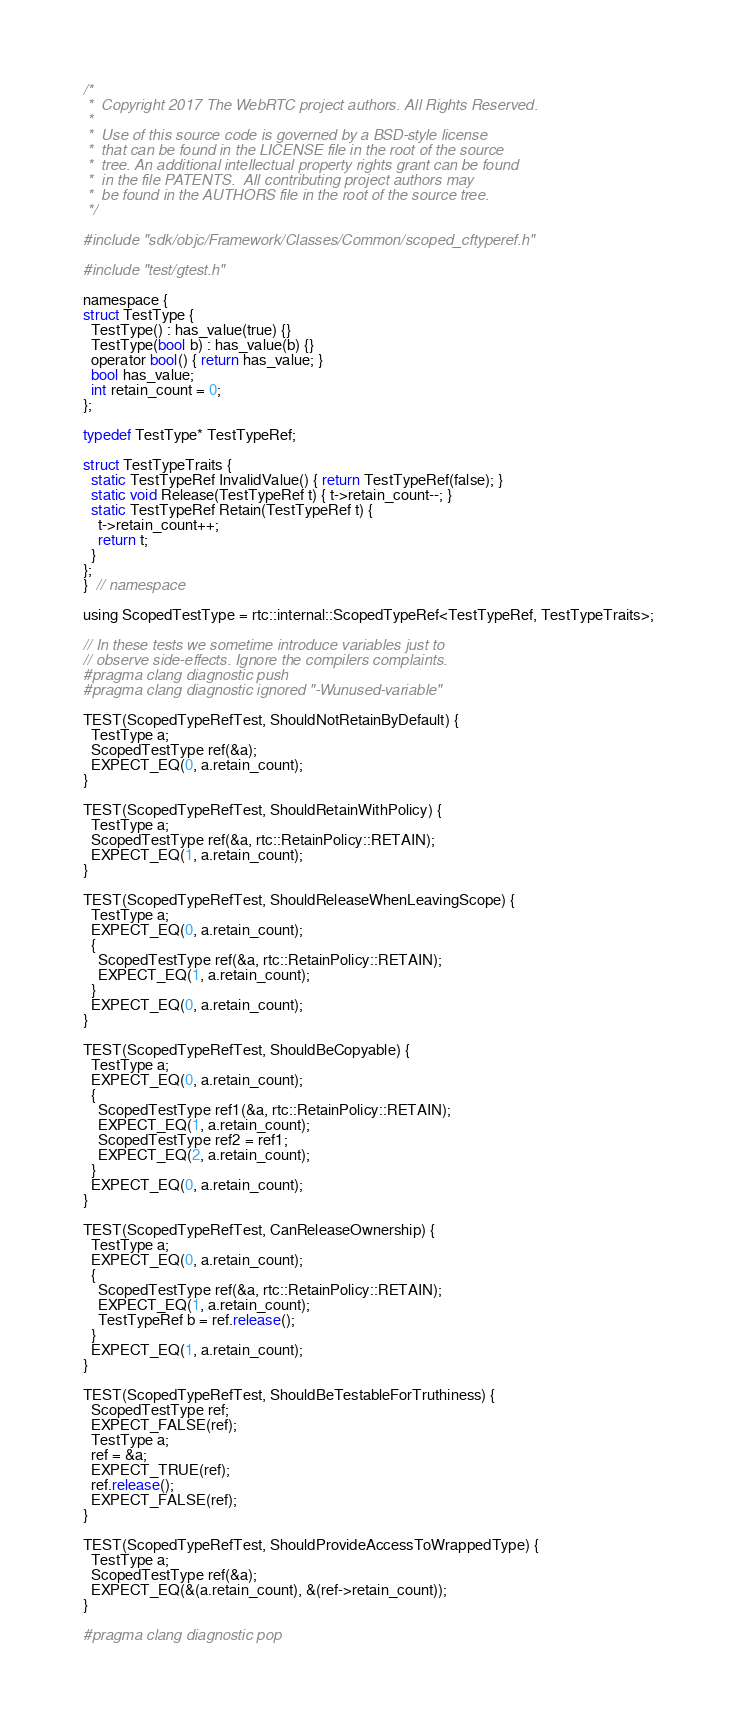Convert code to text. <code><loc_0><loc_0><loc_500><loc_500><_ObjectiveC_>/*
 *  Copyright 2017 The WebRTC project authors. All Rights Reserved.
 *
 *  Use of this source code is governed by a BSD-style license
 *  that can be found in the LICENSE file in the root of the source
 *  tree. An additional intellectual property rights grant can be found
 *  in the file PATENTS.  All contributing project authors may
 *  be found in the AUTHORS file in the root of the source tree.
 */

#include "sdk/objc/Framework/Classes/Common/scoped_cftyperef.h"

#include "test/gtest.h"

namespace {
struct TestType {
  TestType() : has_value(true) {}
  TestType(bool b) : has_value(b) {}
  operator bool() { return has_value; }
  bool has_value;
  int retain_count = 0;
};

typedef TestType* TestTypeRef;

struct TestTypeTraits {
  static TestTypeRef InvalidValue() { return TestTypeRef(false); }
  static void Release(TestTypeRef t) { t->retain_count--; }
  static TestTypeRef Retain(TestTypeRef t) {
    t->retain_count++;
    return t;
  }
};
}  // namespace

using ScopedTestType = rtc::internal::ScopedTypeRef<TestTypeRef, TestTypeTraits>;

// In these tests we sometime introduce variables just to
// observe side-effects. Ignore the compilers complaints.
#pragma clang diagnostic push
#pragma clang diagnostic ignored "-Wunused-variable"

TEST(ScopedTypeRefTest, ShouldNotRetainByDefault) {
  TestType a;
  ScopedTestType ref(&a);
  EXPECT_EQ(0, a.retain_count);
}

TEST(ScopedTypeRefTest, ShouldRetainWithPolicy) {
  TestType a;
  ScopedTestType ref(&a, rtc::RetainPolicy::RETAIN);
  EXPECT_EQ(1, a.retain_count);
}

TEST(ScopedTypeRefTest, ShouldReleaseWhenLeavingScope) {
  TestType a;
  EXPECT_EQ(0, a.retain_count);
  {
    ScopedTestType ref(&a, rtc::RetainPolicy::RETAIN);
    EXPECT_EQ(1, a.retain_count);
  }
  EXPECT_EQ(0, a.retain_count);
}

TEST(ScopedTypeRefTest, ShouldBeCopyable) {
  TestType a;
  EXPECT_EQ(0, a.retain_count);
  {
    ScopedTestType ref1(&a, rtc::RetainPolicy::RETAIN);
    EXPECT_EQ(1, a.retain_count);
    ScopedTestType ref2 = ref1;
    EXPECT_EQ(2, a.retain_count);
  }
  EXPECT_EQ(0, a.retain_count);
}

TEST(ScopedTypeRefTest, CanReleaseOwnership) {
  TestType a;
  EXPECT_EQ(0, a.retain_count);
  {
    ScopedTestType ref(&a, rtc::RetainPolicy::RETAIN);
    EXPECT_EQ(1, a.retain_count);
    TestTypeRef b = ref.release();
  }
  EXPECT_EQ(1, a.retain_count);
}

TEST(ScopedTypeRefTest, ShouldBeTestableForTruthiness) {
  ScopedTestType ref;
  EXPECT_FALSE(ref);
  TestType a;
  ref = &a;
  EXPECT_TRUE(ref);
  ref.release();
  EXPECT_FALSE(ref);
}

TEST(ScopedTypeRefTest, ShouldProvideAccessToWrappedType) {
  TestType a;
  ScopedTestType ref(&a);
  EXPECT_EQ(&(a.retain_count), &(ref->retain_count));
}

#pragma clang diagnostic pop
</code> 